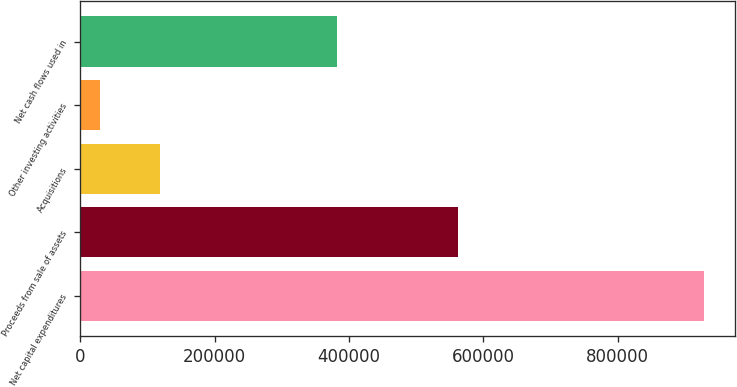Convert chart to OTSL. <chart><loc_0><loc_0><loc_500><loc_500><bar_chart><fcel>Net capital expenditures<fcel>Proceeds from sale of assets<fcel>Acquisitions<fcel>Other investing activities<fcel>Net cash flows used in<nl><fcel>928574<fcel>561739<fcel>118992<fcel>29039<fcel>382356<nl></chart> 